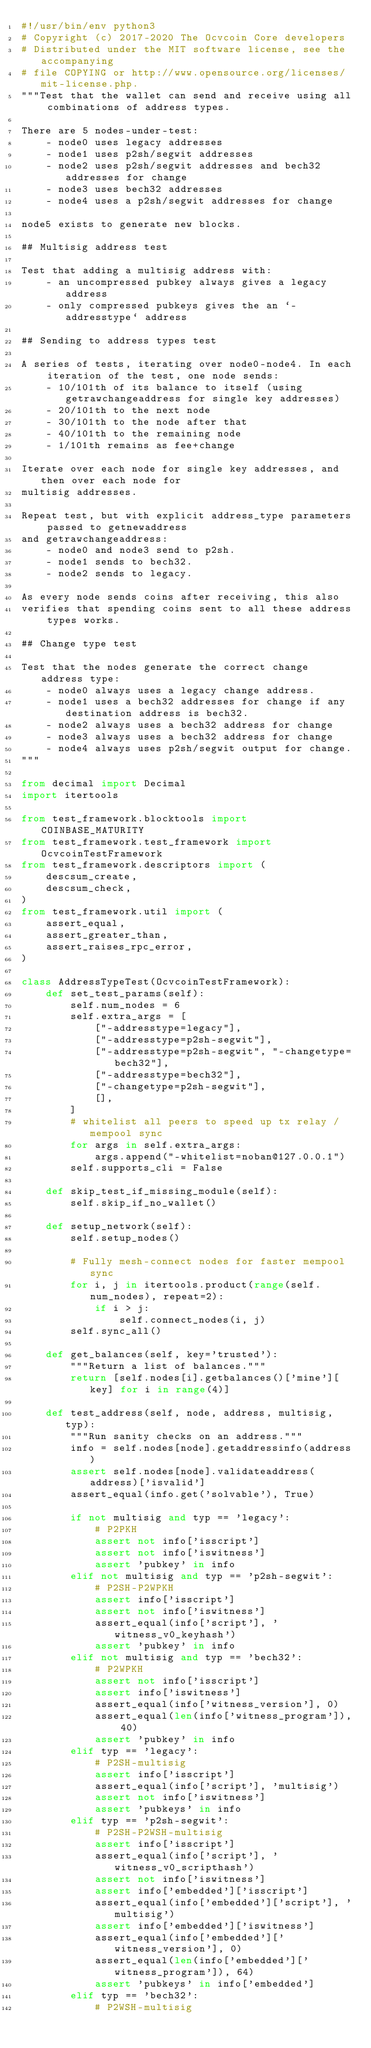<code> <loc_0><loc_0><loc_500><loc_500><_Python_>#!/usr/bin/env python3
# Copyright (c) 2017-2020 The Ocvcoin Core developers
# Distributed under the MIT software license, see the accompanying
# file COPYING or http://www.opensource.org/licenses/mit-license.php.
"""Test that the wallet can send and receive using all combinations of address types.

There are 5 nodes-under-test:
    - node0 uses legacy addresses
    - node1 uses p2sh/segwit addresses
    - node2 uses p2sh/segwit addresses and bech32 addresses for change
    - node3 uses bech32 addresses
    - node4 uses a p2sh/segwit addresses for change

node5 exists to generate new blocks.

## Multisig address test

Test that adding a multisig address with:
    - an uncompressed pubkey always gives a legacy address
    - only compressed pubkeys gives the an `-addresstype` address

## Sending to address types test

A series of tests, iterating over node0-node4. In each iteration of the test, one node sends:
    - 10/101th of its balance to itself (using getrawchangeaddress for single key addresses)
    - 20/101th to the next node
    - 30/101th to the node after that
    - 40/101th to the remaining node
    - 1/101th remains as fee+change

Iterate over each node for single key addresses, and then over each node for
multisig addresses.

Repeat test, but with explicit address_type parameters passed to getnewaddress
and getrawchangeaddress:
    - node0 and node3 send to p2sh.
    - node1 sends to bech32.
    - node2 sends to legacy.

As every node sends coins after receiving, this also
verifies that spending coins sent to all these address types works.

## Change type test

Test that the nodes generate the correct change address type:
    - node0 always uses a legacy change address.
    - node1 uses a bech32 addresses for change if any destination address is bech32.
    - node2 always uses a bech32 address for change
    - node3 always uses a bech32 address for change
    - node4 always uses p2sh/segwit output for change.
"""

from decimal import Decimal
import itertools

from test_framework.blocktools import COINBASE_MATURITY
from test_framework.test_framework import OcvcoinTestFramework
from test_framework.descriptors import (
    descsum_create,
    descsum_check,
)
from test_framework.util import (
    assert_equal,
    assert_greater_than,
    assert_raises_rpc_error,
)

class AddressTypeTest(OcvcoinTestFramework):
    def set_test_params(self):
        self.num_nodes = 6
        self.extra_args = [
            ["-addresstype=legacy"],
            ["-addresstype=p2sh-segwit"],
            ["-addresstype=p2sh-segwit", "-changetype=bech32"],
            ["-addresstype=bech32"],
            ["-changetype=p2sh-segwit"],
            [],
        ]
        # whitelist all peers to speed up tx relay / mempool sync
        for args in self.extra_args:
            args.append("-whitelist=noban@127.0.0.1")
        self.supports_cli = False

    def skip_test_if_missing_module(self):
        self.skip_if_no_wallet()

    def setup_network(self):
        self.setup_nodes()

        # Fully mesh-connect nodes for faster mempool sync
        for i, j in itertools.product(range(self.num_nodes), repeat=2):
            if i > j:
                self.connect_nodes(i, j)
        self.sync_all()

    def get_balances(self, key='trusted'):
        """Return a list of balances."""
        return [self.nodes[i].getbalances()['mine'][key] for i in range(4)]

    def test_address(self, node, address, multisig, typ):
        """Run sanity checks on an address."""
        info = self.nodes[node].getaddressinfo(address)
        assert self.nodes[node].validateaddress(address)['isvalid']
        assert_equal(info.get('solvable'), True)

        if not multisig and typ == 'legacy':
            # P2PKH
            assert not info['isscript']
            assert not info['iswitness']
            assert 'pubkey' in info
        elif not multisig and typ == 'p2sh-segwit':
            # P2SH-P2WPKH
            assert info['isscript']
            assert not info['iswitness']
            assert_equal(info['script'], 'witness_v0_keyhash')
            assert 'pubkey' in info
        elif not multisig and typ == 'bech32':
            # P2WPKH
            assert not info['isscript']
            assert info['iswitness']
            assert_equal(info['witness_version'], 0)
            assert_equal(len(info['witness_program']), 40)
            assert 'pubkey' in info
        elif typ == 'legacy':
            # P2SH-multisig
            assert info['isscript']
            assert_equal(info['script'], 'multisig')
            assert not info['iswitness']
            assert 'pubkeys' in info
        elif typ == 'p2sh-segwit':
            # P2SH-P2WSH-multisig
            assert info['isscript']
            assert_equal(info['script'], 'witness_v0_scripthash')
            assert not info['iswitness']
            assert info['embedded']['isscript']
            assert_equal(info['embedded']['script'], 'multisig')
            assert info['embedded']['iswitness']
            assert_equal(info['embedded']['witness_version'], 0)
            assert_equal(len(info['embedded']['witness_program']), 64)
            assert 'pubkeys' in info['embedded']
        elif typ == 'bech32':
            # P2WSH-multisig</code> 